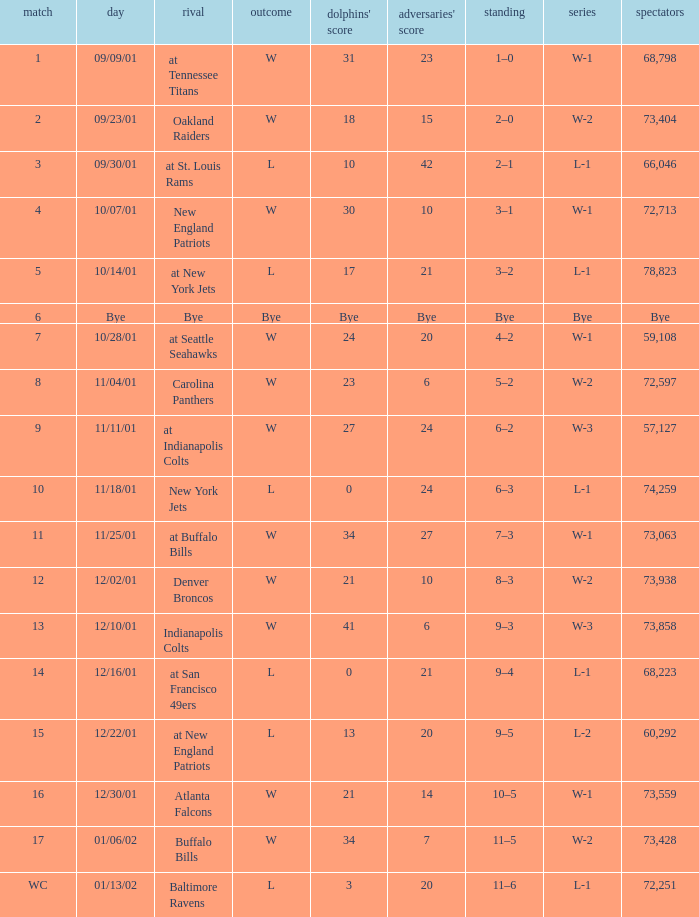Which opponent had 73,428 in attendance? Buffalo Bills. 